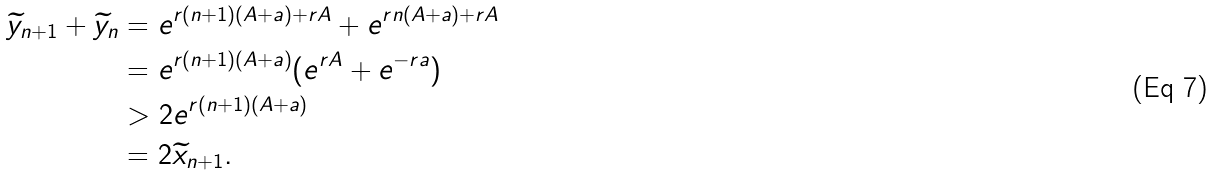<formula> <loc_0><loc_0><loc_500><loc_500>\widetilde { y } _ { n + 1 } + \widetilde { y } _ { n } & = e ^ { r ( n + 1 ) ( A + a ) + r A } + e ^ { r n ( A + a ) + r A } \\ & = e ^ { r ( n + 1 ) ( A + a ) } ( e ^ { r A } + e ^ { - r a } ) \\ & > 2 e ^ { r ( n + 1 ) ( A + a ) } \\ & = 2 \widetilde { x } _ { n + 1 } .</formula> 